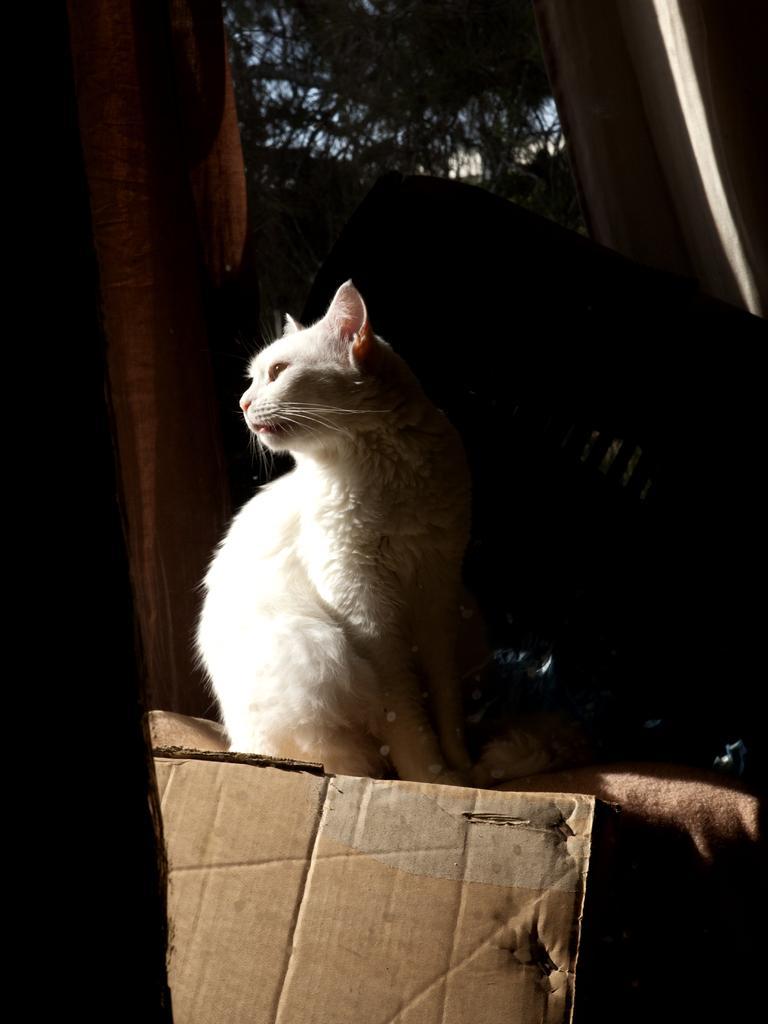In one or two sentences, can you explain what this image depicts? In the image there is a white cat standing on cloth in front of cardboard, in the back it seems to be a tree. 